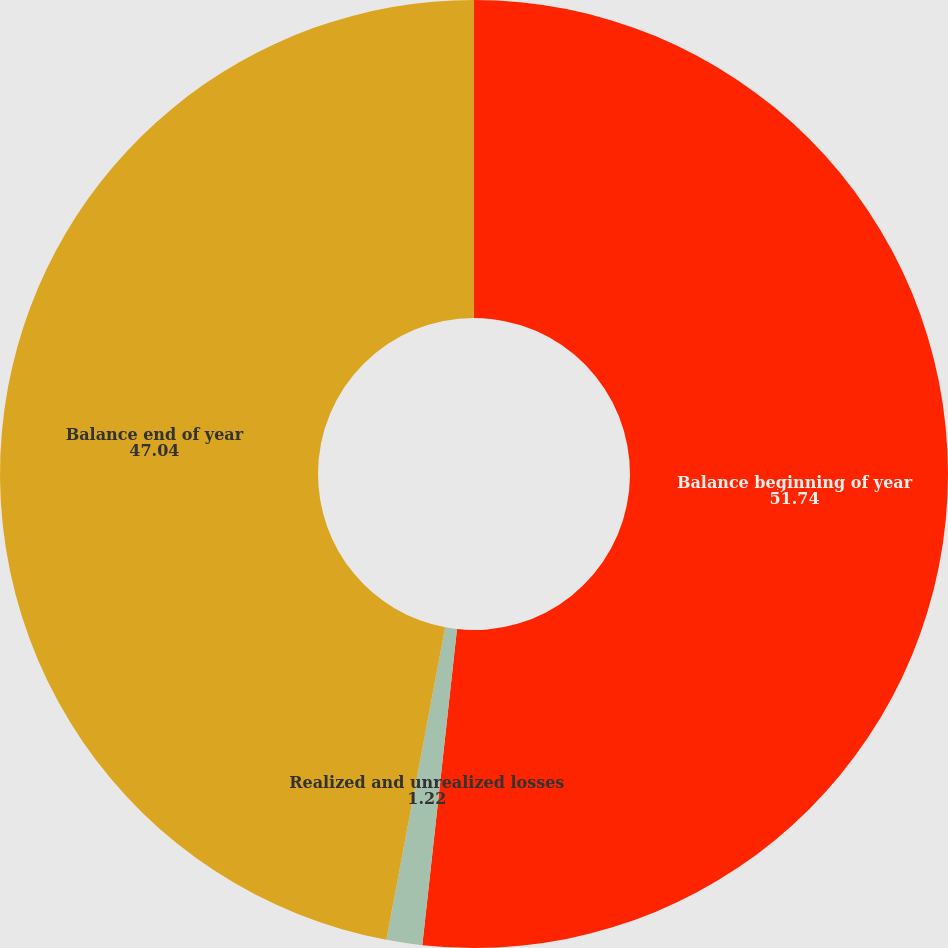<chart> <loc_0><loc_0><loc_500><loc_500><pie_chart><fcel>Balance beginning of year<fcel>Realized and unrealized losses<fcel>Balance end of year<nl><fcel>51.74%<fcel>1.22%<fcel>47.04%<nl></chart> 